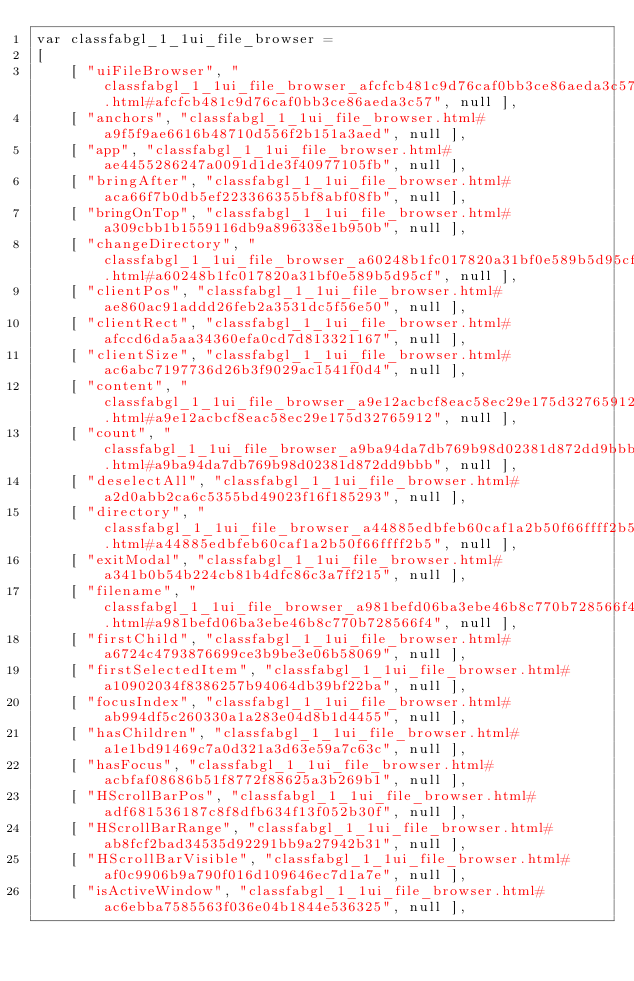<code> <loc_0><loc_0><loc_500><loc_500><_JavaScript_>var classfabgl_1_1ui_file_browser =
[
    [ "uiFileBrowser", "classfabgl_1_1ui_file_browser_afcfcb481c9d76caf0bb3ce86aeda3c57.html#afcfcb481c9d76caf0bb3ce86aeda3c57", null ],
    [ "anchors", "classfabgl_1_1ui_file_browser.html#a9f5f9ae6616b48710d556f2b151a3aed", null ],
    [ "app", "classfabgl_1_1ui_file_browser.html#ae4455286247a0091d1de3f40977105fb", null ],
    [ "bringAfter", "classfabgl_1_1ui_file_browser.html#aca66f7b0db5ef223366355bf8abf08fb", null ],
    [ "bringOnTop", "classfabgl_1_1ui_file_browser.html#a309cbb1b1559116db9a896338e1b950b", null ],
    [ "changeDirectory", "classfabgl_1_1ui_file_browser_a60248b1fc017820a31bf0e589b5d95cf.html#a60248b1fc017820a31bf0e589b5d95cf", null ],
    [ "clientPos", "classfabgl_1_1ui_file_browser.html#ae860ac91addd26feb2a3531dc5f56e50", null ],
    [ "clientRect", "classfabgl_1_1ui_file_browser.html#afccd6da5aa34360efa0cd7d813321167", null ],
    [ "clientSize", "classfabgl_1_1ui_file_browser.html#ac6abc7197736d26b3f9029ac1541f0d4", null ],
    [ "content", "classfabgl_1_1ui_file_browser_a9e12acbcf8eac58ec29e175d32765912.html#a9e12acbcf8eac58ec29e175d32765912", null ],
    [ "count", "classfabgl_1_1ui_file_browser_a9ba94da7db769b98d02381d872dd9bbb.html#a9ba94da7db769b98d02381d872dd9bbb", null ],
    [ "deselectAll", "classfabgl_1_1ui_file_browser.html#a2d0abb2ca6c5355bd49023f16f185293", null ],
    [ "directory", "classfabgl_1_1ui_file_browser_a44885edbfeb60caf1a2b50f66ffff2b5.html#a44885edbfeb60caf1a2b50f66ffff2b5", null ],
    [ "exitModal", "classfabgl_1_1ui_file_browser.html#a341b0b54b224cb81b4dfc86c3a7ff215", null ],
    [ "filename", "classfabgl_1_1ui_file_browser_a981befd06ba3ebe46b8c770b728566f4.html#a981befd06ba3ebe46b8c770b728566f4", null ],
    [ "firstChild", "classfabgl_1_1ui_file_browser.html#a6724c4793876699ce3b9be3e06b58069", null ],
    [ "firstSelectedItem", "classfabgl_1_1ui_file_browser.html#a10902034f8386257b94064db39bf22ba", null ],
    [ "focusIndex", "classfabgl_1_1ui_file_browser.html#ab994df5c260330a1a283e04d8b1d4455", null ],
    [ "hasChildren", "classfabgl_1_1ui_file_browser.html#a1e1bd91469c7a0d321a3d63e59a7c63c", null ],
    [ "hasFocus", "classfabgl_1_1ui_file_browser.html#acbfaf08686b51f8772f88625a3b269b1", null ],
    [ "HScrollBarPos", "classfabgl_1_1ui_file_browser.html#adf681536187c8f8dfb634f13f052b30f", null ],
    [ "HScrollBarRange", "classfabgl_1_1ui_file_browser.html#ab8fcf2bad34535d92291bb9a27942b31", null ],
    [ "HScrollBarVisible", "classfabgl_1_1ui_file_browser.html#af0c9906b9a790f016d109646ec7d1a7e", null ],
    [ "isActiveWindow", "classfabgl_1_1ui_file_browser.html#ac6ebba7585563f036e04b1844e536325", null ],</code> 